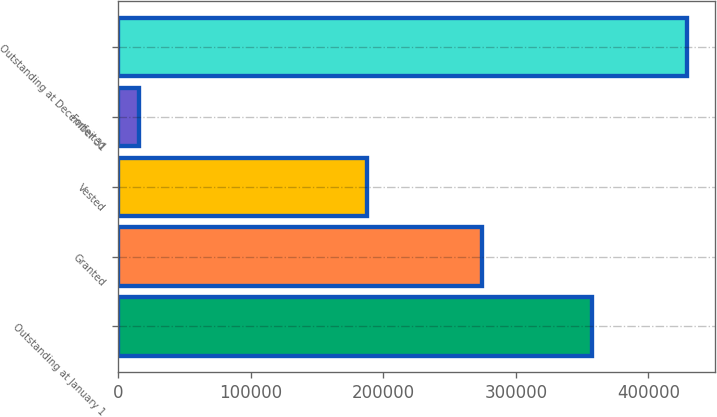Convert chart to OTSL. <chart><loc_0><loc_0><loc_500><loc_500><bar_chart><fcel>Outstanding at January 1<fcel>Granted<fcel>Vested<fcel>Forfeited<fcel>Outstanding at December 31<nl><fcel>357750<fcel>274715<fcel>187397<fcel>16027<fcel>429041<nl></chart> 